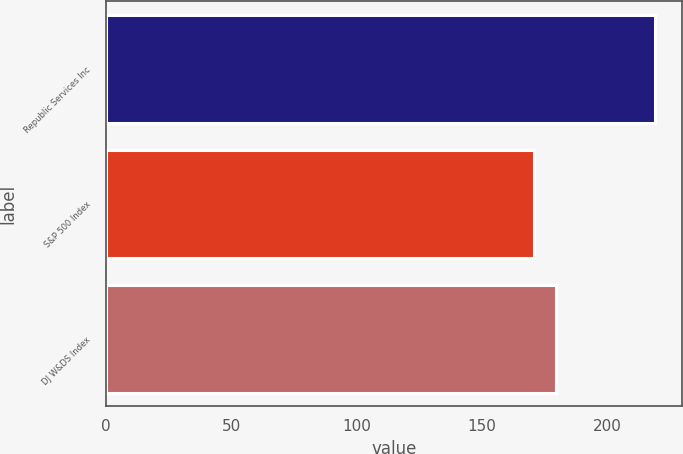Convert chart to OTSL. <chart><loc_0><loc_0><loc_500><loc_500><bar_chart><fcel>Republic Services Inc<fcel>S&P 500 Index<fcel>DJ W&DS Index<nl><fcel>218.82<fcel>170.84<fcel>179.38<nl></chart> 